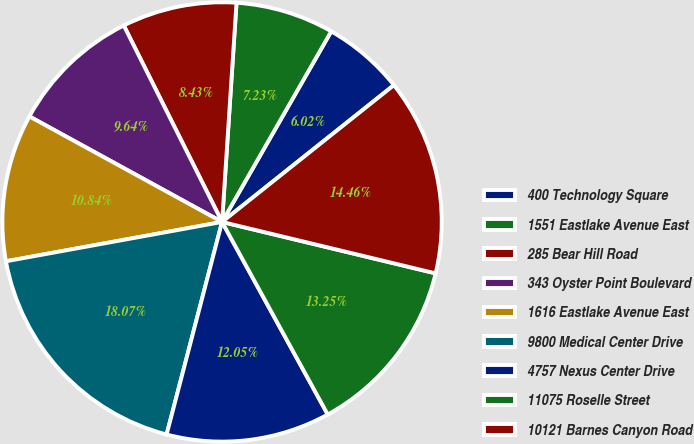<chart> <loc_0><loc_0><loc_500><loc_500><pie_chart><fcel>400 Technology Square<fcel>1551 Eastlake Avenue East<fcel>285 Bear Hill Road<fcel>343 Oyster Point Boulevard<fcel>1616 Eastlake Avenue East<fcel>9800 Medical Center Drive<fcel>4757 Nexus Center Drive<fcel>11075 Roselle Street<fcel>10121 Barnes Canyon Road<nl><fcel>6.02%<fcel>7.23%<fcel>8.43%<fcel>9.64%<fcel>10.84%<fcel>18.07%<fcel>12.05%<fcel>13.25%<fcel>14.46%<nl></chart> 